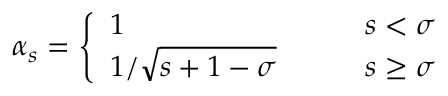Convert formula to latex. <formula><loc_0><loc_0><loc_500><loc_500>\alpha _ { s } = \left \{ \begin{array} { l l } { 1 \quad } & { s < \sigma } \\ { 1 / \sqrt { s + 1 - \sigma } \quad } & { s \geq \sigma } \end{array}</formula> 